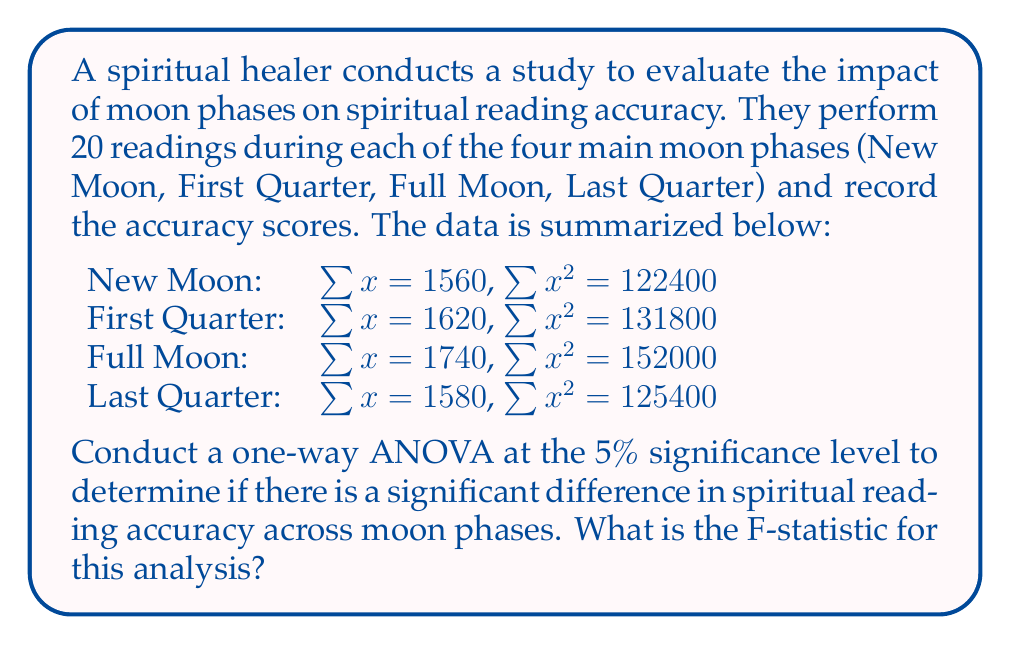Teach me how to tackle this problem. To conduct a one-way ANOVA, we need to follow these steps:

1. Calculate the total sum of squares (SST)
2. Calculate the between-group sum of squares (SSB)
3. Calculate the within-group sum of squares (SSW)
4. Calculate the degrees of freedom
5. Calculate the mean squares
6. Calculate the F-statistic

Step 1: Calculate SST
First, we need to find the grand mean:
$$\bar{x} = \frac{1560 + 1620 + 1740 + 1580}{80} = 81.25$$

Now, we can calculate SST:
$$SST = (122400 + 131800 + 152000 + 125400) - 80(81.25)^2 = 2600$$

Step 2: Calculate SSB
We need to calculate the group means:
$$\bar{x}_1 = \frac{1560}{20} = 78, \bar{x}_2 = \frac{1620}{20} = 81, \bar{x}_3 = \frac{1740}{20} = 87, \bar{x}_4 = \frac{1580}{20} = 79$$

Now we can calculate SSB:
$$SSB = 20[(78 - 81.25)^2 + (81 - 81.25)^2 + (87 - 81.25)^2 + (79 - 81.25)^2] = 1020$$

Step 3: Calculate SSW
$$SSW = SST - SSB = 2600 - 1020 = 1580$$

Step 4: Calculate degrees of freedom
Between-group df: $k - 1 = 4 - 1 = 3$
Within-group df: $N - k = 80 - 4 = 76$

Step 5: Calculate mean squares
$$MSB = \frac{SSB}{df_B} = \frac{1020}{3} = 340$$
$$MSW = \frac{SSW}{df_W} = \frac{1580}{76} = 20.789$$

Step 6: Calculate F-statistic
$$F = \frac{MSB}{MSW} = \frac{340}{20.789} = 16.355$$
Answer: The F-statistic for this one-way ANOVA is approximately 16.355. 